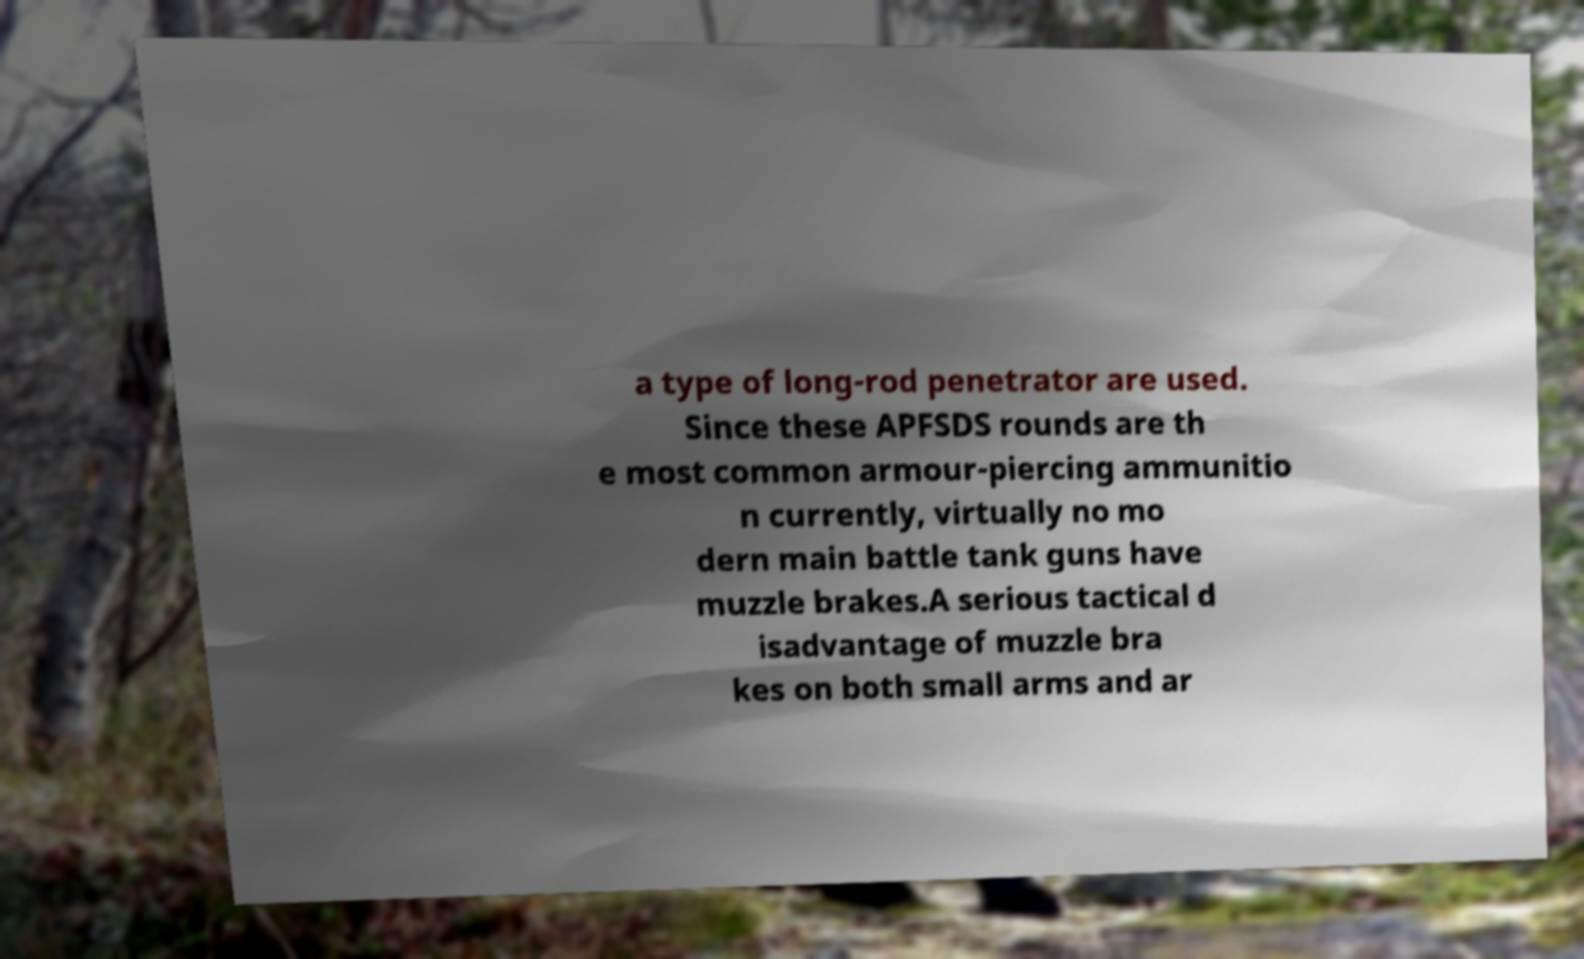Could you extract and type out the text from this image? a type of long-rod penetrator are used. Since these APFSDS rounds are th e most common armour-piercing ammunitio n currently, virtually no mo dern main battle tank guns have muzzle brakes.A serious tactical d isadvantage of muzzle bra kes on both small arms and ar 